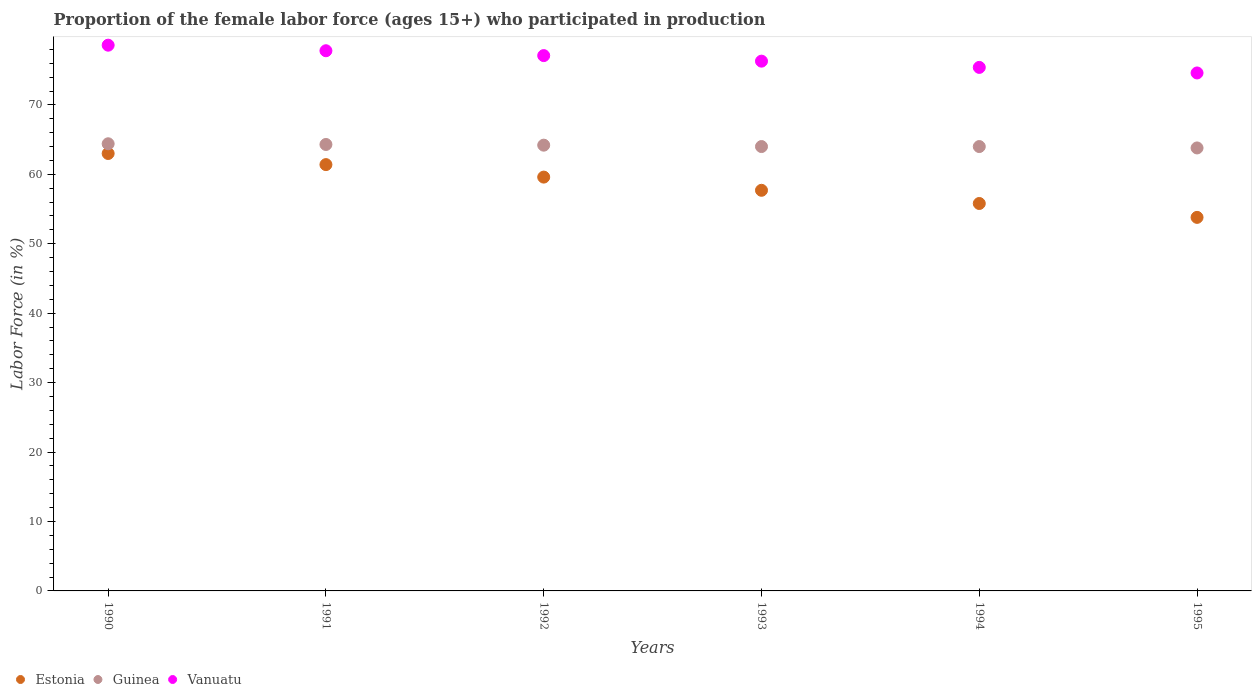Is the number of dotlines equal to the number of legend labels?
Offer a terse response. Yes. What is the proportion of the female labor force who participated in production in Estonia in 1993?
Offer a very short reply. 57.7. Across all years, what is the minimum proportion of the female labor force who participated in production in Estonia?
Offer a terse response. 53.8. In which year was the proportion of the female labor force who participated in production in Guinea maximum?
Offer a terse response. 1990. What is the total proportion of the female labor force who participated in production in Guinea in the graph?
Keep it short and to the point. 384.7. What is the difference between the proportion of the female labor force who participated in production in Vanuatu in 1991 and that in 1995?
Provide a succinct answer. 3.2. What is the difference between the proportion of the female labor force who participated in production in Guinea in 1992 and the proportion of the female labor force who participated in production in Vanuatu in 1994?
Keep it short and to the point. -11.2. What is the average proportion of the female labor force who participated in production in Guinea per year?
Ensure brevity in your answer.  64.12. In the year 1990, what is the difference between the proportion of the female labor force who participated in production in Estonia and proportion of the female labor force who participated in production in Guinea?
Your answer should be very brief. -1.4. In how many years, is the proportion of the female labor force who participated in production in Guinea greater than 50 %?
Offer a very short reply. 6. What is the ratio of the proportion of the female labor force who participated in production in Guinea in 1990 to that in 1991?
Offer a terse response. 1. What is the difference between the highest and the second highest proportion of the female labor force who participated in production in Vanuatu?
Give a very brief answer. 0.8. What is the difference between the highest and the lowest proportion of the female labor force who participated in production in Vanuatu?
Keep it short and to the point. 4. In how many years, is the proportion of the female labor force who participated in production in Estonia greater than the average proportion of the female labor force who participated in production in Estonia taken over all years?
Offer a very short reply. 3. Is the sum of the proportion of the female labor force who participated in production in Vanuatu in 1990 and 1992 greater than the maximum proportion of the female labor force who participated in production in Estonia across all years?
Your answer should be very brief. Yes. Does the proportion of the female labor force who participated in production in Guinea monotonically increase over the years?
Make the answer very short. No. How many dotlines are there?
Offer a very short reply. 3. What is the difference between two consecutive major ticks on the Y-axis?
Ensure brevity in your answer.  10. Where does the legend appear in the graph?
Give a very brief answer. Bottom left. How many legend labels are there?
Provide a short and direct response. 3. How are the legend labels stacked?
Your answer should be very brief. Horizontal. What is the title of the graph?
Your response must be concise. Proportion of the female labor force (ages 15+) who participated in production. What is the label or title of the Y-axis?
Make the answer very short. Labor Force (in %). What is the Labor Force (in %) of Estonia in 1990?
Offer a terse response. 63. What is the Labor Force (in %) of Guinea in 1990?
Your answer should be very brief. 64.4. What is the Labor Force (in %) in Vanuatu in 1990?
Provide a short and direct response. 78.6. What is the Labor Force (in %) in Estonia in 1991?
Make the answer very short. 61.4. What is the Labor Force (in %) in Guinea in 1991?
Provide a succinct answer. 64.3. What is the Labor Force (in %) of Vanuatu in 1991?
Your response must be concise. 77.8. What is the Labor Force (in %) in Estonia in 1992?
Provide a short and direct response. 59.6. What is the Labor Force (in %) of Guinea in 1992?
Provide a succinct answer. 64.2. What is the Labor Force (in %) in Vanuatu in 1992?
Give a very brief answer. 77.1. What is the Labor Force (in %) of Estonia in 1993?
Your response must be concise. 57.7. What is the Labor Force (in %) in Guinea in 1993?
Offer a very short reply. 64. What is the Labor Force (in %) of Vanuatu in 1993?
Your response must be concise. 76.3. What is the Labor Force (in %) in Estonia in 1994?
Your answer should be very brief. 55.8. What is the Labor Force (in %) of Guinea in 1994?
Give a very brief answer. 64. What is the Labor Force (in %) in Vanuatu in 1994?
Make the answer very short. 75.4. What is the Labor Force (in %) in Estonia in 1995?
Your response must be concise. 53.8. What is the Labor Force (in %) in Guinea in 1995?
Give a very brief answer. 63.8. What is the Labor Force (in %) of Vanuatu in 1995?
Make the answer very short. 74.6. Across all years, what is the maximum Labor Force (in %) in Estonia?
Provide a short and direct response. 63. Across all years, what is the maximum Labor Force (in %) of Guinea?
Your response must be concise. 64.4. Across all years, what is the maximum Labor Force (in %) of Vanuatu?
Provide a short and direct response. 78.6. Across all years, what is the minimum Labor Force (in %) in Estonia?
Make the answer very short. 53.8. Across all years, what is the minimum Labor Force (in %) of Guinea?
Your response must be concise. 63.8. Across all years, what is the minimum Labor Force (in %) in Vanuatu?
Your response must be concise. 74.6. What is the total Labor Force (in %) in Estonia in the graph?
Your response must be concise. 351.3. What is the total Labor Force (in %) of Guinea in the graph?
Provide a succinct answer. 384.7. What is the total Labor Force (in %) in Vanuatu in the graph?
Ensure brevity in your answer.  459.8. What is the difference between the Labor Force (in %) of Estonia in 1990 and that in 1991?
Make the answer very short. 1.6. What is the difference between the Labor Force (in %) of Guinea in 1990 and that in 1991?
Your answer should be very brief. 0.1. What is the difference between the Labor Force (in %) of Estonia in 1990 and that in 1992?
Make the answer very short. 3.4. What is the difference between the Labor Force (in %) of Guinea in 1990 and that in 1992?
Make the answer very short. 0.2. What is the difference between the Labor Force (in %) in Vanuatu in 1990 and that in 1992?
Your response must be concise. 1.5. What is the difference between the Labor Force (in %) of Estonia in 1990 and that in 1993?
Your response must be concise. 5.3. What is the difference between the Labor Force (in %) of Guinea in 1990 and that in 1993?
Give a very brief answer. 0.4. What is the difference between the Labor Force (in %) of Vanuatu in 1990 and that in 1993?
Provide a succinct answer. 2.3. What is the difference between the Labor Force (in %) of Estonia in 1990 and that in 1994?
Offer a very short reply. 7.2. What is the difference between the Labor Force (in %) in Vanuatu in 1990 and that in 1994?
Make the answer very short. 3.2. What is the difference between the Labor Force (in %) of Guinea in 1990 and that in 1995?
Your answer should be compact. 0.6. What is the difference between the Labor Force (in %) of Estonia in 1991 and that in 1992?
Ensure brevity in your answer.  1.8. What is the difference between the Labor Force (in %) of Guinea in 1991 and that in 1992?
Your response must be concise. 0.1. What is the difference between the Labor Force (in %) of Estonia in 1991 and that in 1993?
Make the answer very short. 3.7. What is the difference between the Labor Force (in %) in Vanuatu in 1991 and that in 1993?
Your answer should be compact. 1.5. What is the difference between the Labor Force (in %) of Estonia in 1991 and that in 1994?
Provide a succinct answer. 5.6. What is the difference between the Labor Force (in %) of Guinea in 1991 and that in 1994?
Give a very brief answer. 0.3. What is the difference between the Labor Force (in %) of Estonia in 1991 and that in 1995?
Your response must be concise. 7.6. What is the difference between the Labor Force (in %) of Guinea in 1991 and that in 1995?
Give a very brief answer. 0.5. What is the difference between the Labor Force (in %) of Estonia in 1992 and that in 1993?
Provide a short and direct response. 1.9. What is the difference between the Labor Force (in %) of Guinea in 1992 and that in 1993?
Keep it short and to the point. 0.2. What is the difference between the Labor Force (in %) of Estonia in 1992 and that in 1994?
Make the answer very short. 3.8. What is the difference between the Labor Force (in %) of Guinea in 1992 and that in 1994?
Make the answer very short. 0.2. What is the difference between the Labor Force (in %) in Vanuatu in 1992 and that in 1994?
Offer a very short reply. 1.7. What is the difference between the Labor Force (in %) in Estonia in 1994 and that in 1995?
Provide a succinct answer. 2. What is the difference between the Labor Force (in %) of Guinea in 1994 and that in 1995?
Provide a succinct answer. 0.2. What is the difference between the Labor Force (in %) of Vanuatu in 1994 and that in 1995?
Your answer should be compact. 0.8. What is the difference between the Labor Force (in %) of Estonia in 1990 and the Labor Force (in %) of Guinea in 1991?
Make the answer very short. -1.3. What is the difference between the Labor Force (in %) in Estonia in 1990 and the Labor Force (in %) in Vanuatu in 1991?
Provide a succinct answer. -14.8. What is the difference between the Labor Force (in %) in Guinea in 1990 and the Labor Force (in %) in Vanuatu in 1991?
Provide a succinct answer. -13.4. What is the difference between the Labor Force (in %) of Estonia in 1990 and the Labor Force (in %) of Guinea in 1992?
Provide a short and direct response. -1.2. What is the difference between the Labor Force (in %) of Estonia in 1990 and the Labor Force (in %) of Vanuatu in 1992?
Your answer should be compact. -14.1. What is the difference between the Labor Force (in %) of Estonia in 1990 and the Labor Force (in %) of Vanuatu in 1994?
Provide a succinct answer. -12.4. What is the difference between the Labor Force (in %) in Estonia in 1991 and the Labor Force (in %) in Vanuatu in 1992?
Provide a short and direct response. -15.7. What is the difference between the Labor Force (in %) of Estonia in 1991 and the Labor Force (in %) of Vanuatu in 1993?
Your response must be concise. -14.9. What is the difference between the Labor Force (in %) in Guinea in 1991 and the Labor Force (in %) in Vanuatu in 1993?
Offer a very short reply. -12. What is the difference between the Labor Force (in %) of Estonia in 1991 and the Labor Force (in %) of Guinea in 1994?
Keep it short and to the point. -2.6. What is the difference between the Labor Force (in %) in Estonia in 1991 and the Labor Force (in %) in Vanuatu in 1994?
Offer a terse response. -14. What is the difference between the Labor Force (in %) in Estonia in 1991 and the Labor Force (in %) in Guinea in 1995?
Provide a short and direct response. -2.4. What is the difference between the Labor Force (in %) in Estonia in 1991 and the Labor Force (in %) in Vanuatu in 1995?
Give a very brief answer. -13.2. What is the difference between the Labor Force (in %) of Guinea in 1991 and the Labor Force (in %) of Vanuatu in 1995?
Give a very brief answer. -10.3. What is the difference between the Labor Force (in %) in Estonia in 1992 and the Labor Force (in %) in Vanuatu in 1993?
Your answer should be compact. -16.7. What is the difference between the Labor Force (in %) of Guinea in 1992 and the Labor Force (in %) of Vanuatu in 1993?
Your answer should be very brief. -12.1. What is the difference between the Labor Force (in %) in Estonia in 1992 and the Labor Force (in %) in Guinea in 1994?
Your answer should be very brief. -4.4. What is the difference between the Labor Force (in %) in Estonia in 1992 and the Labor Force (in %) in Vanuatu in 1994?
Offer a very short reply. -15.8. What is the difference between the Labor Force (in %) of Estonia in 1992 and the Labor Force (in %) of Vanuatu in 1995?
Provide a short and direct response. -15. What is the difference between the Labor Force (in %) of Guinea in 1992 and the Labor Force (in %) of Vanuatu in 1995?
Keep it short and to the point. -10.4. What is the difference between the Labor Force (in %) in Estonia in 1993 and the Labor Force (in %) in Vanuatu in 1994?
Ensure brevity in your answer.  -17.7. What is the difference between the Labor Force (in %) in Estonia in 1993 and the Labor Force (in %) in Vanuatu in 1995?
Offer a terse response. -16.9. What is the difference between the Labor Force (in %) in Estonia in 1994 and the Labor Force (in %) in Guinea in 1995?
Give a very brief answer. -8. What is the difference between the Labor Force (in %) of Estonia in 1994 and the Labor Force (in %) of Vanuatu in 1995?
Offer a very short reply. -18.8. What is the difference between the Labor Force (in %) in Guinea in 1994 and the Labor Force (in %) in Vanuatu in 1995?
Your response must be concise. -10.6. What is the average Labor Force (in %) in Estonia per year?
Your answer should be compact. 58.55. What is the average Labor Force (in %) in Guinea per year?
Keep it short and to the point. 64.12. What is the average Labor Force (in %) in Vanuatu per year?
Ensure brevity in your answer.  76.63. In the year 1990, what is the difference between the Labor Force (in %) of Estonia and Labor Force (in %) of Vanuatu?
Keep it short and to the point. -15.6. In the year 1991, what is the difference between the Labor Force (in %) of Estonia and Labor Force (in %) of Vanuatu?
Provide a short and direct response. -16.4. In the year 1992, what is the difference between the Labor Force (in %) in Estonia and Labor Force (in %) in Vanuatu?
Offer a terse response. -17.5. In the year 1992, what is the difference between the Labor Force (in %) of Guinea and Labor Force (in %) of Vanuatu?
Provide a succinct answer. -12.9. In the year 1993, what is the difference between the Labor Force (in %) of Estonia and Labor Force (in %) of Guinea?
Your answer should be compact. -6.3. In the year 1993, what is the difference between the Labor Force (in %) of Estonia and Labor Force (in %) of Vanuatu?
Provide a succinct answer. -18.6. In the year 1993, what is the difference between the Labor Force (in %) of Guinea and Labor Force (in %) of Vanuatu?
Your answer should be very brief. -12.3. In the year 1994, what is the difference between the Labor Force (in %) in Estonia and Labor Force (in %) in Vanuatu?
Your answer should be very brief. -19.6. In the year 1994, what is the difference between the Labor Force (in %) of Guinea and Labor Force (in %) of Vanuatu?
Provide a succinct answer. -11.4. In the year 1995, what is the difference between the Labor Force (in %) in Estonia and Labor Force (in %) in Vanuatu?
Offer a terse response. -20.8. In the year 1995, what is the difference between the Labor Force (in %) in Guinea and Labor Force (in %) in Vanuatu?
Provide a succinct answer. -10.8. What is the ratio of the Labor Force (in %) of Estonia in 1990 to that in 1991?
Give a very brief answer. 1.03. What is the ratio of the Labor Force (in %) in Guinea in 1990 to that in 1991?
Provide a short and direct response. 1. What is the ratio of the Labor Force (in %) in Vanuatu in 1990 to that in 1991?
Your answer should be compact. 1.01. What is the ratio of the Labor Force (in %) in Estonia in 1990 to that in 1992?
Your answer should be compact. 1.06. What is the ratio of the Labor Force (in %) in Guinea in 1990 to that in 1992?
Provide a short and direct response. 1. What is the ratio of the Labor Force (in %) of Vanuatu in 1990 to that in 1992?
Ensure brevity in your answer.  1.02. What is the ratio of the Labor Force (in %) of Estonia in 1990 to that in 1993?
Keep it short and to the point. 1.09. What is the ratio of the Labor Force (in %) of Guinea in 1990 to that in 1993?
Give a very brief answer. 1.01. What is the ratio of the Labor Force (in %) in Vanuatu in 1990 to that in 1993?
Keep it short and to the point. 1.03. What is the ratio of the Labor Force (in %) of Estonia in 1990 to that in 1994?
Offer a terse response. 1.13. What is the ratio of the Labor Force (in %) in Vanuatu in 1990 to that in 1994?
Offer a very short reply. 1.04. What is the ratio of the Labor Force (in %) of Estonia in 1990 to that in 1995?
Give a very brief answer. 1.17. What is the ratio of the Labor Force (in %) of Guinea in 1990 to that in 1995?
Give a very brief answer. 1.01. What is the ratio of the Labor Force (in %) in Vanuatu in 1990 to that in 1995?
Your answer should be compact. 1.05. What is the ratio of the Labor Force (in %) of Estonia in 1991 to that in 1992?
Your answer should be compact. 1.03. What is the ratio of the Labor Force (in %) in Vanuatu in 1991 to that in 1992?
Make the answer very short. 1.01. What is the ratio of the Labor Force (in %) of Estonia in 1991 to that in 1993?
Keep it short and to the point. 1.06. What is the ratio of the Labor Force (in %) of Guinea in 1991 to that in 1993?
Make the answer very short. 1. What is the ratio of the Labor Force (in %) in Vanuatu in 1991 to that in 1993?
Your answer should be compact. 1.02. What is the ratio of the Labor Force (in %) of Estonia in 1991 to that in 1994?
Your response must be concise. 1.1. What is the ratio of the Labor Force (in %) in Guinea in 1991 to that in 1994?
Your answer should be compact. 1. What is the ratio of the Labor Force (in %) in Vanuatu in 1991 to that in 1994?
Your response must be concise. 1.03. What is the ratio of the Labor Force (in %) in Estonia in 1991 to that in 1995?
Your answer should be compact. 1.14. What is the ratio of the Labor Force (in %) in Vanuatu in 1991 to that in 1995?
Your response must be concise. 1.04. What is the ratio of the Labor Force (in %) of Estonia in 1992 to that in 1993?
Provide a succinct answer. 1.03. What is the ratio of the Labor Force (in %) in Vanuatu in 1992 to that in 1993?
Provide a short and direct response. 1.01. What is the ratio of the Labor Force (in %) of Estonia in 1992 to that in 1994?
Your response must be concise. 1.07. What is the ratio of the Labor Force (in %) of Guinea in 1992 to that in 1994?
Offer a very short reply. 1. What is the ratio of the Labor Force (in %) of Vanuatu in 1992 to that in 1994?
Offer a terse response. 1.02. What is the ratio of the Labor Force (in %) in Estonia in 1992 to that in 1995?
Offer a terse response. 1.11. What is the ratio of the Labor Force (in %) in Vanuatu in 1992 to that in 1995?
Keep it short and to the point. 1.03. What is the ratio of the Labor Force (in %) of Estonia in 1993 to that in 1994?
Your answer should be very brief. 1.03. What is the ratio of the Labor Force (in %) of Guinea in 1993 to that in 1994?
Keep it short and to the point. 1. What is the ratio of the Labor Force (in %) in Vanuatu in 1993 to that in 1994?
Give a very brief answer. 1.01. What is the ratio of the Labor Force (in %) in Estonia in 1993 to that in 1995?
Your answer should be very brief. 1.07. What is the ratio of the Labor Force (in %) in Vanuatu in 1993 to that in 1995?
Make the answer very short. 1.02. What is the ratio of the Labor Force (in %) in Estonia in 1994 to that in 1995?
Keep it short and to the point. 1.04. What is the ratio of the Labor Force (in %) in Guinea in 1994 to that in 1995?
Your answer should be very brief. 1. What is the ratio of the Labor Force (in %) of Vanuatu in 1994 to that in 1995?
Offer a very short reply. 1.01. What is the difference between the highest and the second highest Labor Force (in %) of Vanuatu?
Make the answer very short. 0.8. What is the difference between the highest and the lowest Labor Force (in %) of Estonia?
Make the answer very short. 9.2. What is the difference between the highest and the lowest Labor Force (in %) of Vanuatu?
Offer a terse response. 4. 